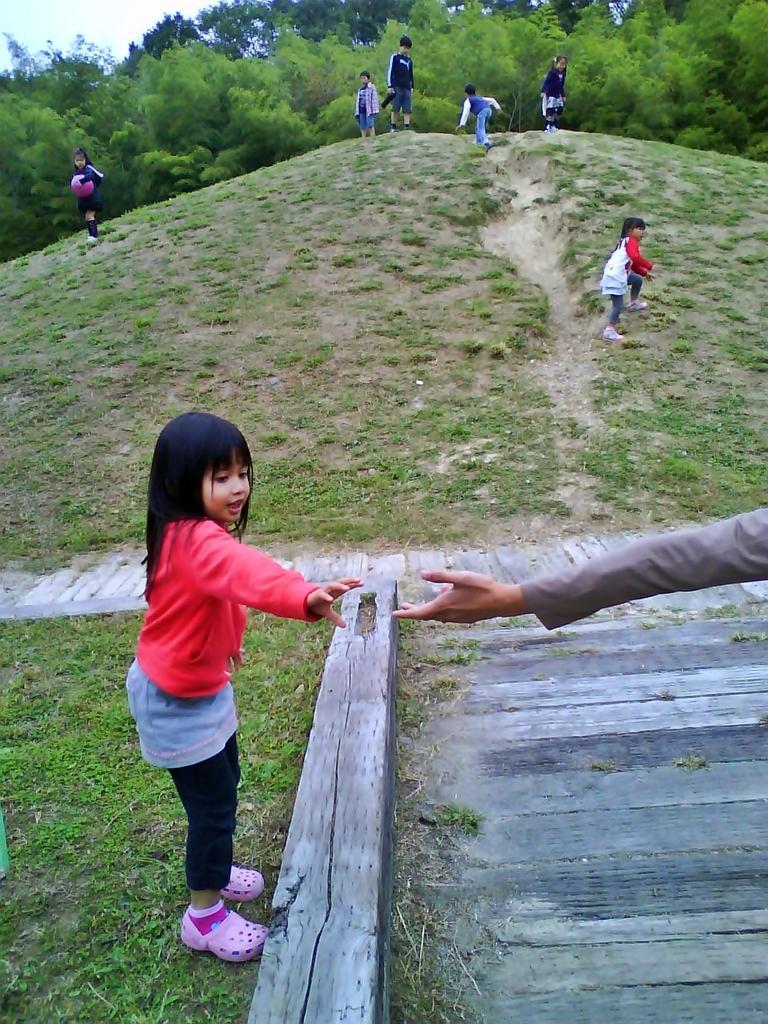How would you summarize this image in a sentence or two? This picture is clicked outside. In the foreground we can see the hand of a person. On the left there is a girl standing on the ground. In the background we can see the group of people seems to be running on the ground and we can see the green grass, trees and the sky. 